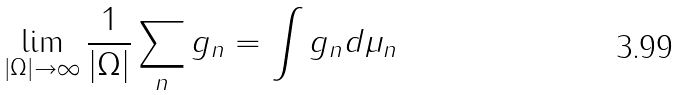Convert formula to latex. <formula><loc_0><loc_0><loc_500><loc_500>\lim _ { \left | \Omega \right | \rightarrow \infty } \frac { 1 } { \left | \Omega \right | } \sum _ { n } g _ { n } = \int g _ { n } d \mu _ { n }</formula> 